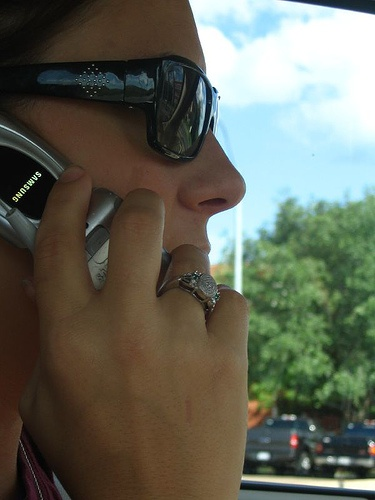Describe the objects in this image and their specific colors. I can see people in black, maroon, and gray tones, cell phone in black and gray tones, truck in black, gray, purple, and darkblue tones, car in black, gray, blue, and darkblue tones, and truck in black, gray, blue, and darkblue tones in this image. 